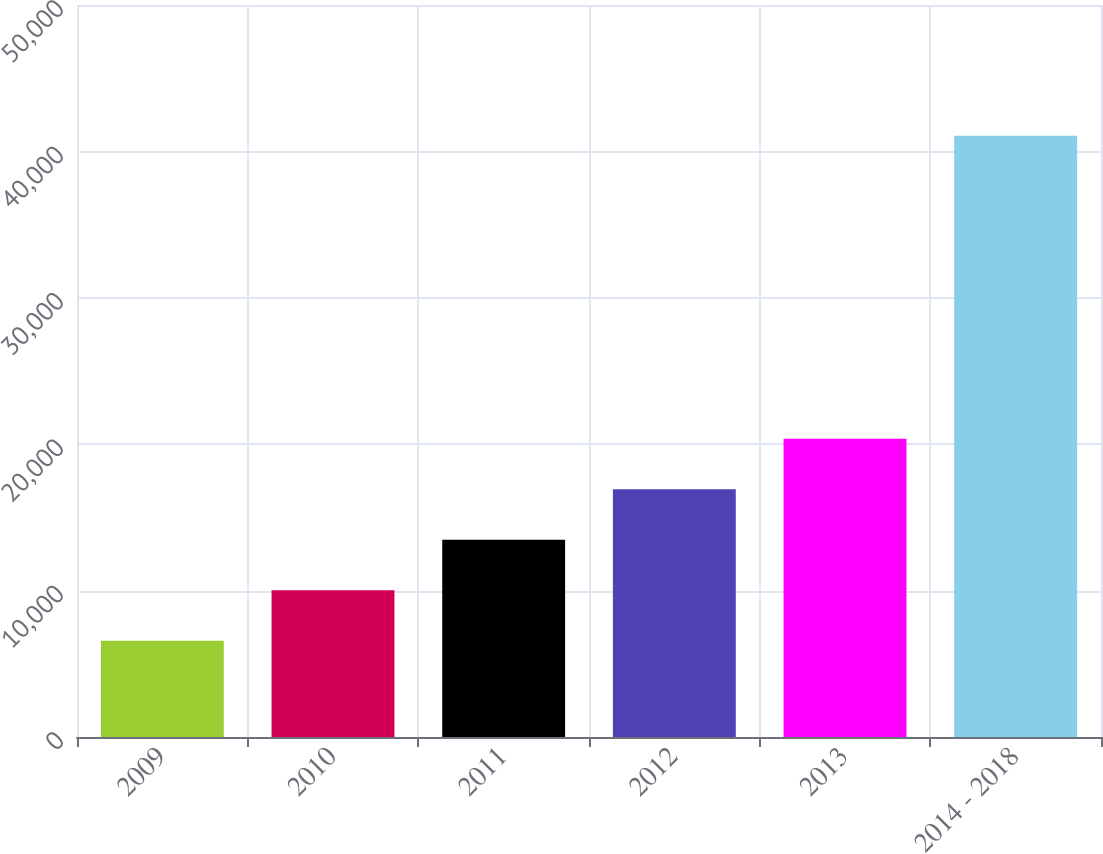Convert chart to OTSL. <chart><loc_0><loc_0><loc_500><loc_500><bar_chart><fcel>2009<fcel>2010<fcel>2011<fcel>2012<fcel>2013<fcel>2014 - 2018<nl><fcel>6581<fcel>10030.2<fcel>13479.4<fcel>16928.6<fcel>20377.8<fcel>41073<nl></chart> 